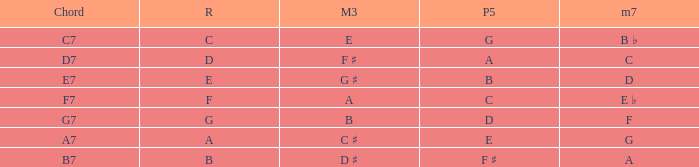What is the Major third with a Perfect fifth that is d? B. 